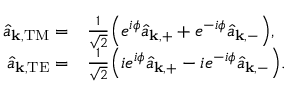Convert formula to latex. <formula><loc_0><loc_0><loc_500><loc_500>\begin{array} { r l } { \hat { a } _ { k , T M } = } & \frac { 1 } { \sqrt { 2 } } \left ( e ^ { i \phi } \hat { a } _ { k , + } + e ^ { - i \phi } \hat { a } _ { k , - } \right ) , } \\ { \hat { a } _ { k , T E } = } & \frac { 1 } { \sqrt { 2 } } \left ( i e ^ { i \phi } \hat { a } _ { k , + } - i e ^ { - i \phi } \hat { a } _ { k , - } \right ) . } \end{array}</formula> 